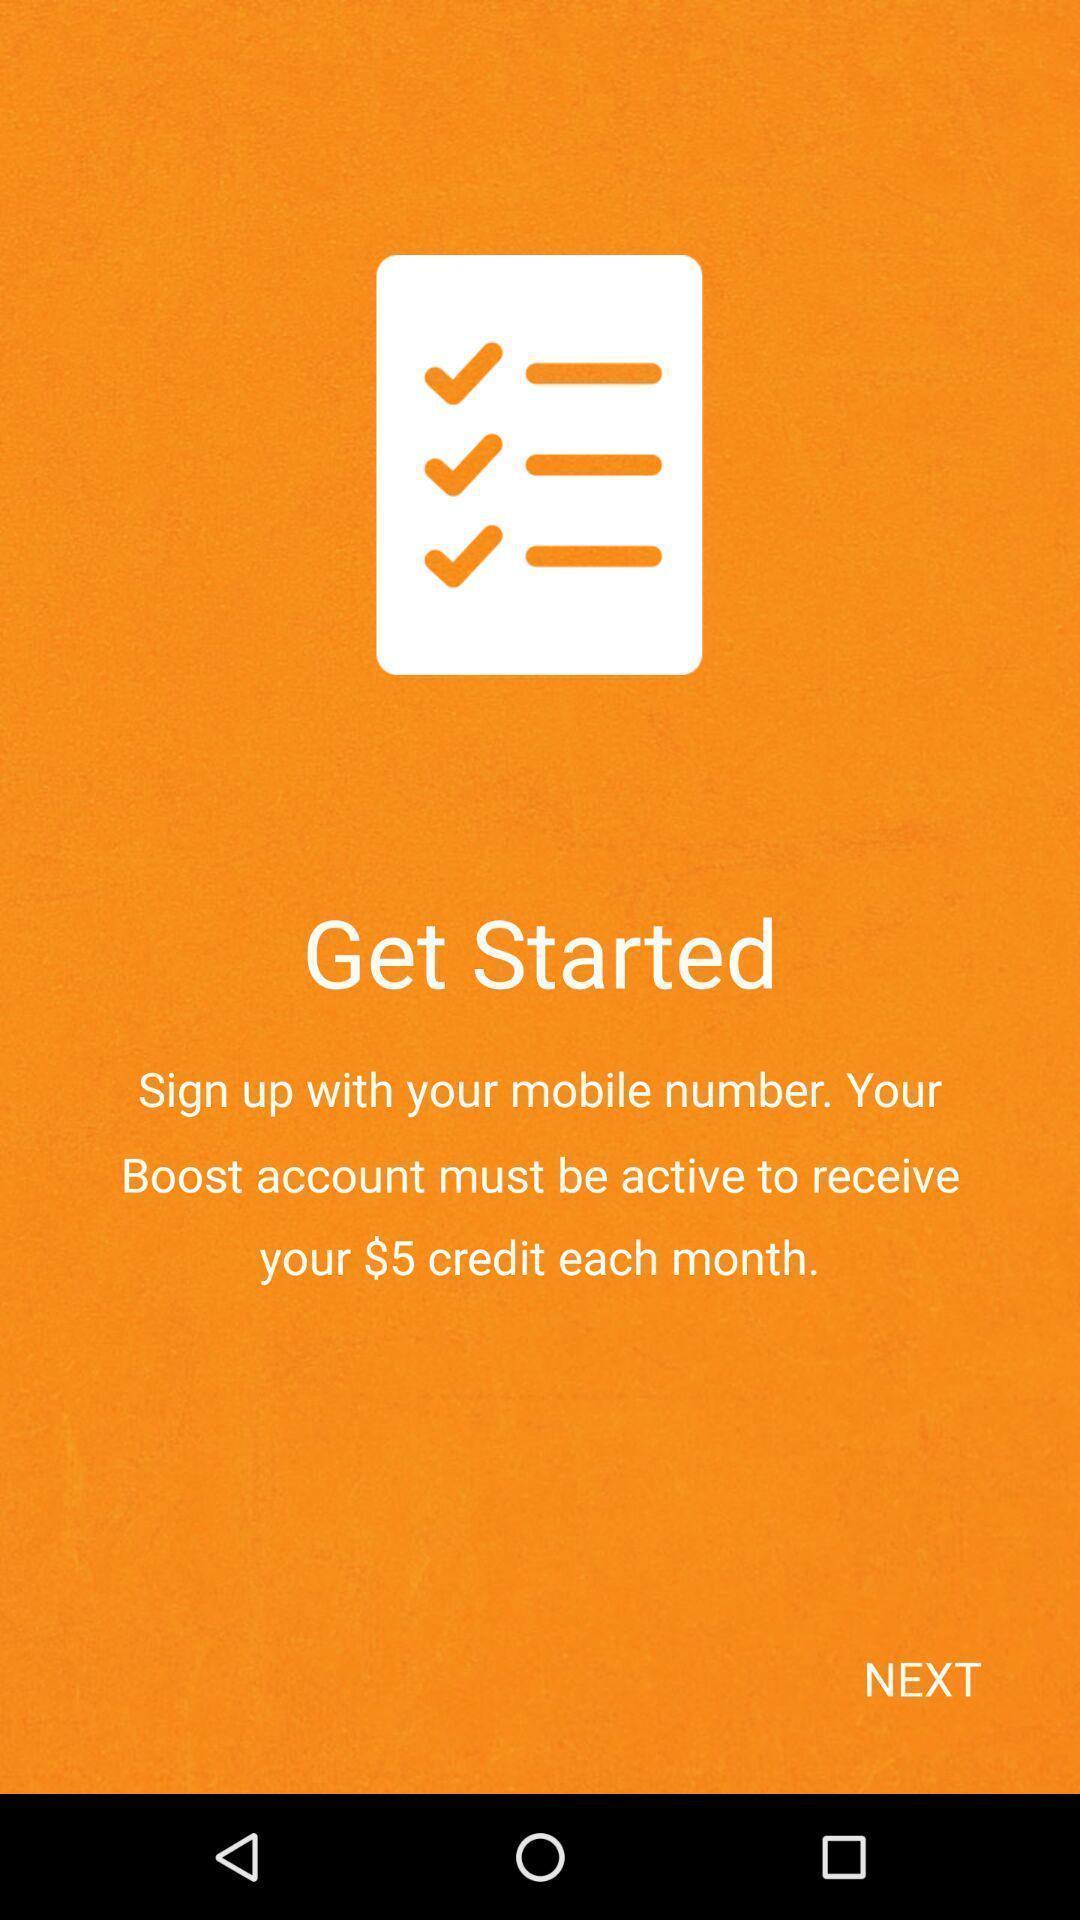Tell me about the visual elements in this screen capture. Welcome to the home page. 